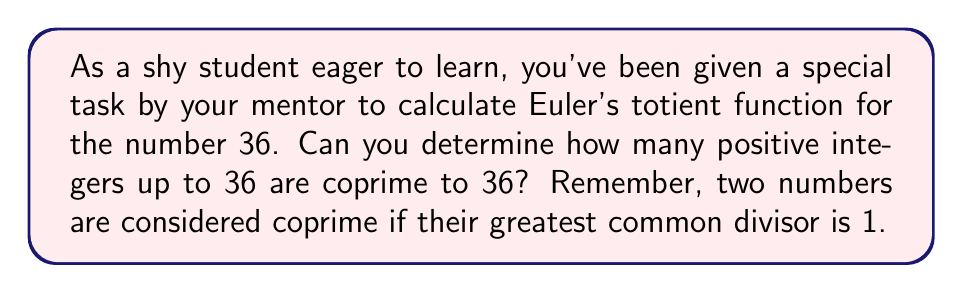Could you help me with this problem? Let's approach this step-by-step:

1) First, recall that Euler's totient function $\phi(n)$ counts the number of integers between 1 and n that are coprime to n.

2) For a prime number p, $\phi(p) = p - 1$, as all numbers less than p are coprime to it.

3) For a prime power $p^k$, $\phi(p^k) = p^k - p^{k-1} = p^k(1 - \frac{1}{p})$.

4) Euler's totient function is multiplicative, meaning for coprime numbers a and b, $\phi(ab) = \phi(a) \cdot \phi(b)$.

5) Now, let's factor 36: $36 = 2^2 \cdot 3^2$

6) Using the properties above:

   $\phi(36) = \phi(2^2) \cdot \phi(3^2)$

7) Calculate $\phi(2^2)$:
   
   $\phi(2^2) = 2^2 - 2^1 = 4 - 2 = 2$

8) Calculate $\phi(3^2)$:
   
   $\phi(3^2) = 3^2 - 3^1 = 9 - 3 = 6$

9) Now, multiply these results:

   $\phi(36) = \phi(2^2) \cdot \phi(3^2) = 2 \cdot 6 = 12$

Therefore, there are 12 numbers between 1 and 36 that are coprime to 36.
Answer: $\phi(36) = 12$ 